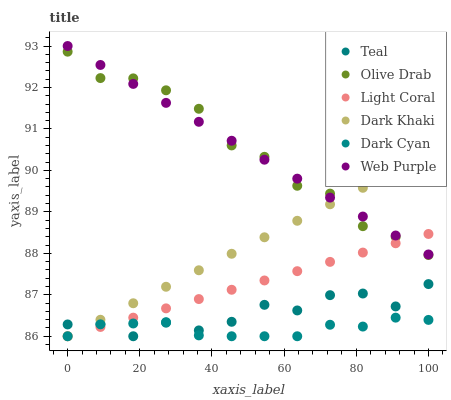Does Dark Cyan have the minimum area under the curve?
Answer yes or no. Yes. Does Web Purple have the maximum area under the curve?
Answer yes or no. Yes. Does Light Coral have the minimum area under the curve?
Answer yes or no. No. Does Light Coral have the maximum area under the curve?
Answer yes or no. No. Is Light Coral the smoothest?
Answer yes or no. Yes. Is Teal the roughest?
Answer yes or no. Yes. Is Web Purple the smoothest?
Answer yes or no. No. Is Web Purple the roughest?
Answer yes or no. No. Does Dark Khaki have the lowest value?
Answer yes or no. Yes. Does Web Purple have the lowest value?
Answer yes or no. No. Does Web Purple have the highest value?
Answer yes or no. Yes. Does Light Coral have the highest value?
Answer yes or no. No. Is Dark Cyan less than Web Purple?
Answer yes or no. Yes. Is Olive Drab greater than Teal?
Answer yes or no. Yes. Does Dark Khaki intersect Web Purple?
Answer yes or no. Yes. Is Dark Khaki less than Web Purple?
Answer yes or no. No. Is Dark Khaki greater than Web Purple?
Answer yes or no. No. Does Dark Cyan intersect Web Purple?
Answer yes or no. No. 